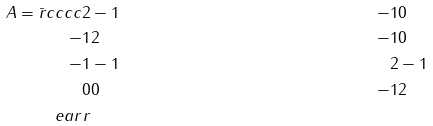<formula> <loc_0><loc_0><loc_500><loc_500>A = \bar { r } { c c c c } 2 & - 1 & - 1 & 0 \\ - 1 & 2 & - 1 & 0 \\ - 1 & - 1 & 2 & - 1 \\ 0 & 0 & - 1 & 2 \\ \ e a r r</formula> 